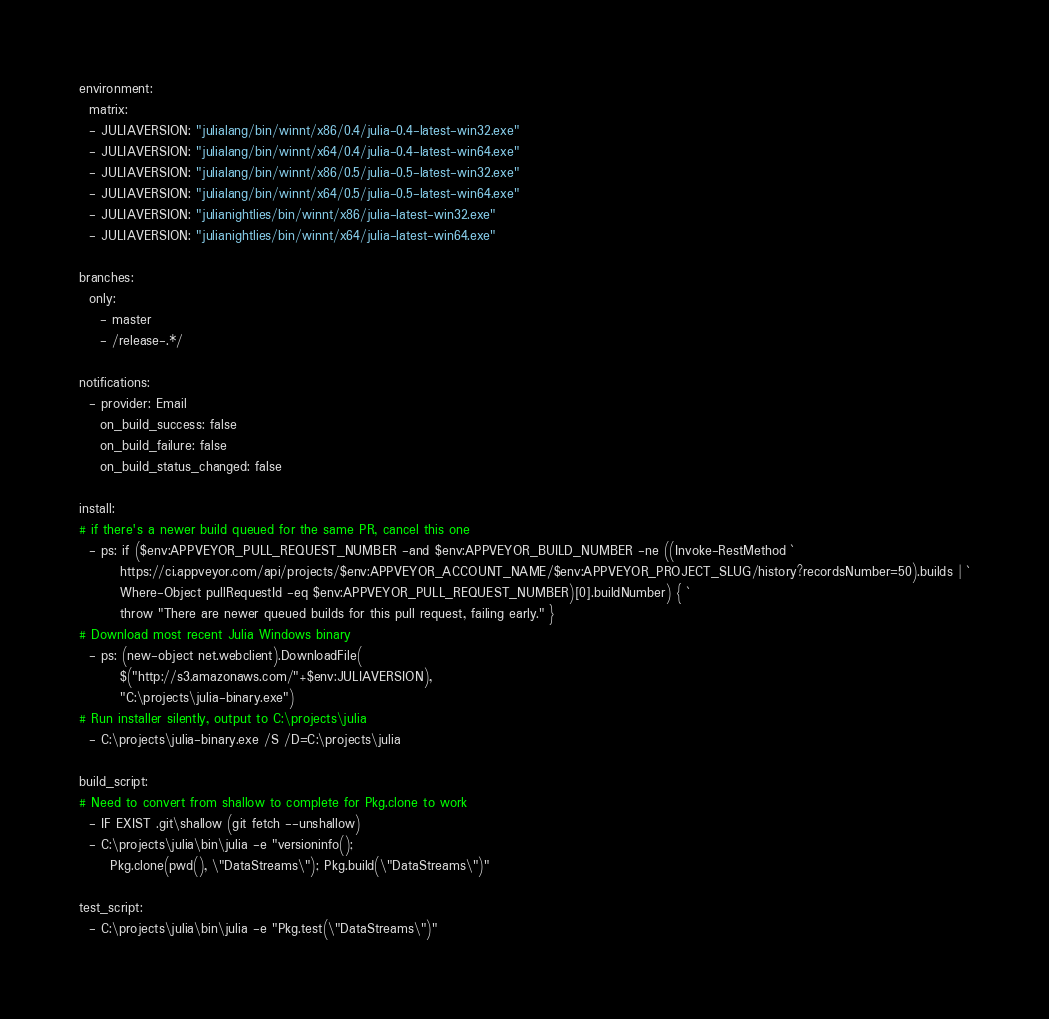<code> <loc_0><loc_0><loc_500><loc_500><_YAML_>environment:
  matrix:
  - JULIAVERSION: "julialang/bin/winnt/x86/0.4/julia-0.4-latest-win32.exe"
  - JULIAVERSION: "julialang/bin/winnt/x64/0.4/julia-0.4-latest-win64.exe"
  - JULIAVERSION: "julialang/bin/winnt/x86/0.5/julia-0.5-latest-win32.exe"
  - JULIAVERSION: "julialang/bin/winnt/x64/0.5/julia-0.5-latest-win64.exe"
  - JULIAVERSION: "julianightlies/bin/winnt/x86/julia-latest-win32.exe"
  - JULIAVERSION: "julianightlies/bin/winnt/x64/julia-latest-win64.exe"

branches:
  only:
    - master
    - /release-.*/

notifications:
  - provider: Email
    on_build_success: false
    on_build_failure: false
    on_build_status_changed: false

install:
# if there's a newer build queued for the same PR, cancel this one
  - ps: if ($env:APPVEYOR_PULL_REQUEST_NUMBER -and $env:APPVEYOR_BUILD_NUMBER -ne ((Invoke-RestMethod `
        https://ci.appveyor.com/api/projects/$env:APPVEYOR_ACCOUNT_NAME/$env:APPVEYOR_PROJECT_SLUG/history?recordsNumber=50).builds | `
        Where-Object pullRequestId -eq $env:APPVEYOR_PULL_REQUEST_NUMBER)[0].buildNumber) { `
        throw "There are newer queued builds for this pull request, failing early." }
# Download most recent Julia Windows binary
  - ps: (new-object net.webclient).DownloadFile(
        $("http://s3.amazonaws.com/"+$env:JULIAVERSION),
        "C:\projects\julia-binary.exe")
# Run installer silently, output to C:\projects\julia
  - C:\projects\julia-binary.exe /S /D=C:\projects\julia

build_script:
# Need to convert from shallow to complete for Pkg.clone to work
  - IF EXIST .git\shallow (git fetch --unshallow)
  - C:\projects\julia\bin\julia -e "versioninfo();
      Pkg.clone(pwd(), \"DataStreams\"); Pkg.build(\"DataStreams\")"

test_script:
  - C:\projects\julia\bin\julia -e "Pkg.test(\"DataStreams\")"
</code> 